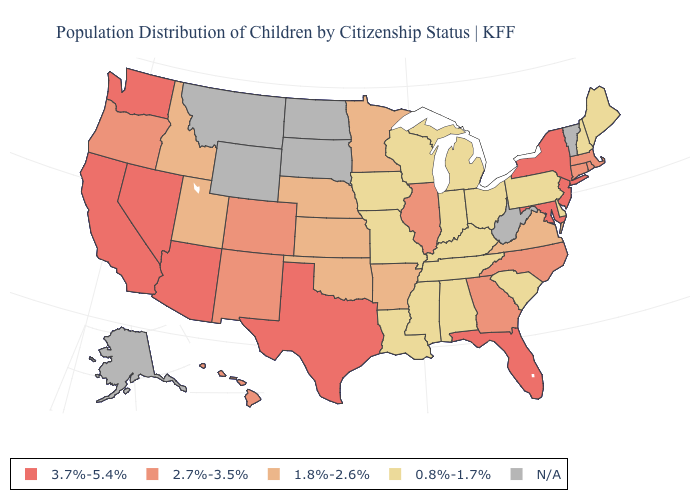Which states have the highest value in the USA?
Quick response, please. Arizona, California, Florida, Maryland, Nevada, New Jersey, New York, Texas, Washington. What is the lowest value in the USA?
Short answer required. 0.8%-1.7%. What is the value of New Mexico?
Answer briefly. 2.7%-3.5%. Which states hav the highest value in the West?
Keep it brief. Arizona, California, Nevada, Washington. Does New Hampshire have the lowest value in the USA?
Keep it brief. Yes. What is the lowest value in the MidWest?
Concise answer only. 0.8%-1.7%. Among the states that border New Mexico , does Texas have the highest value?
Quick response, please. Yes. How many symbols are there in the legend?
Give a very brief answer. 5. What is the lowest value in the USA?
Give a very brief answer. 0.8%-1.7%. What is the lowest value in states that border New Mexico?
Concise answer only. 1.8%-2.6%. Name the states that have a value in the range 0.8%-1.7%?
Short answer required. Alabama, Delaware, Indiana, Iowa, Kentucky, Louisiana, Maine, Michigan, Mississippi, Missouri, New Hampshire, Ohio, Pennsylvania, South Carolina, Tennessee, Wisconsin. Among the states that border New Hampshire , does Massachusetts have the highest value?
Be succinct. Yes. Name the states that have a value in the range 1.8%-2.6%?
Concise answer only. Arkansas, Idaho, Kansas, Minnesota, Nebraska, Oklahoma, Utah, Virginia. 